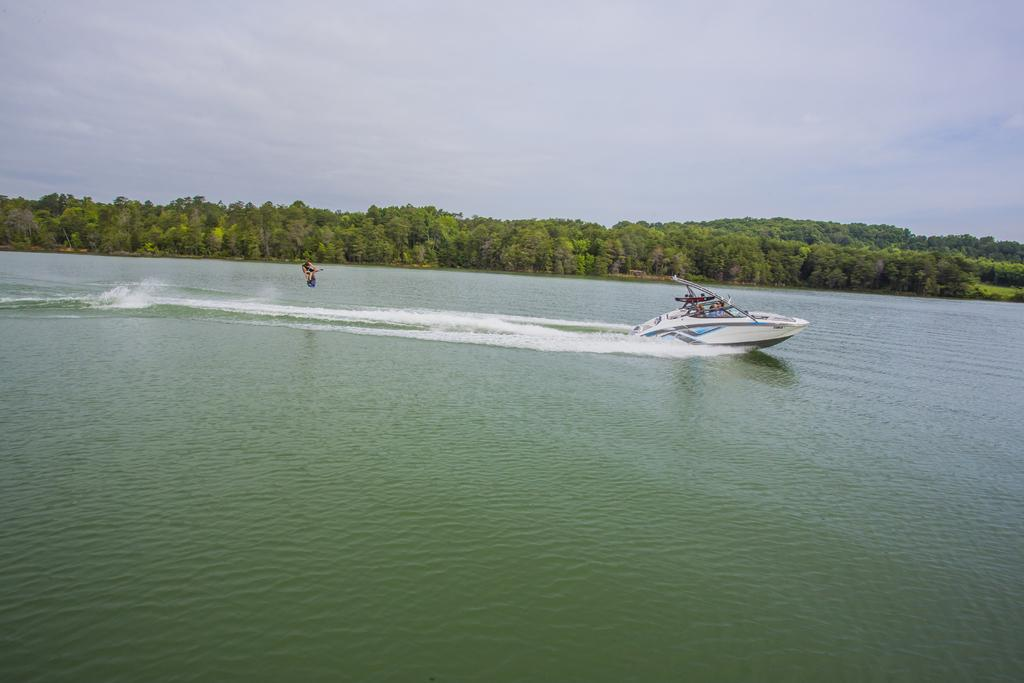What are the people in the image doing? There are persons riding a steamer boat in the image. What type of vegetation can be seen in the image? There are trees visible in the image. What is visible in the background of the image? The sky is visible in the image. What can be seen in the sky? Clouds are present in the sky. What type of basin is being used to collect water from the steamer boat in the image? There is no basin present in the image; it features people riding a steamer boat. What type of plough can be seen in the image? There is no plough present in the image; it features people riding a steamer boat. 